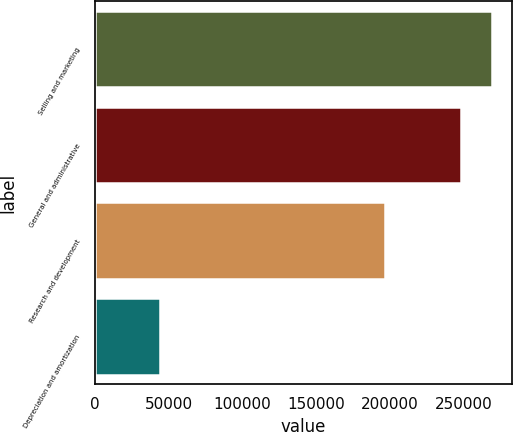Convert chart. <chart><loc_0><loc_0><loc_500><loc_500><bar_chart><fcel>Selling and marketing<fcel>General and administrative<fcel>Research and development<fcel>Depreciation and amortization<nl><fcel>269040<fcel>247828<fcel>196373<fcel>43969<nl></chart> 